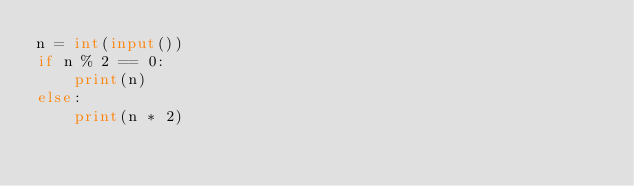Convert code to text. <code><loc_0><loc_0><loc_500><loc_500><_Python_>n = int(input())
if n % 2 == 0:
    print(n)
else:
    print(n * 2)</code> 